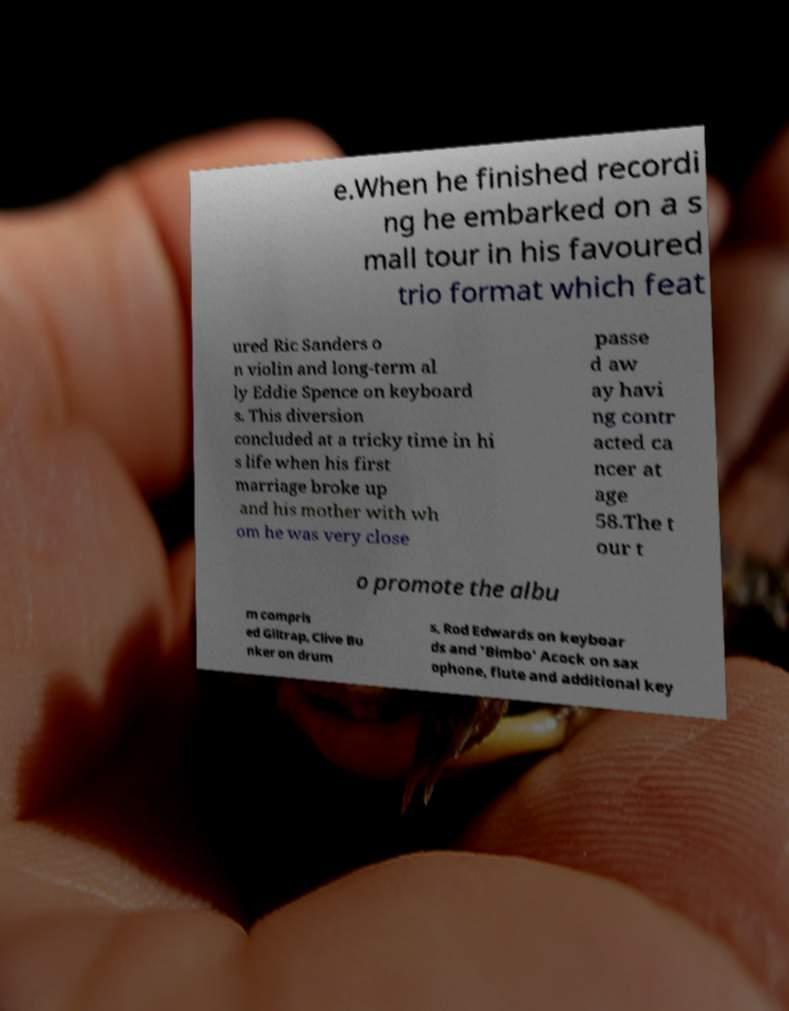Please read and relay the text visible in this image. What does it say? e.When he finished recordi ng he embarked on a s mall tour in his favoured trio format which feat ured Ric Sanders o n violin and long-term al ly Eddie Spence on keyboard s. This diversion concluded at a tricky time in hi s life when his first marriage broke up and his mother with wh om he was very close passe d aw ay havi ng contr acted ca ncer at age 58.The t our t o promote the albu m compris ed Giltrap, Clive Bu nker on drum s, Rod Edwards on keyboar ds and 'Bimbo' Acock on sax ophone, flute and additional key 